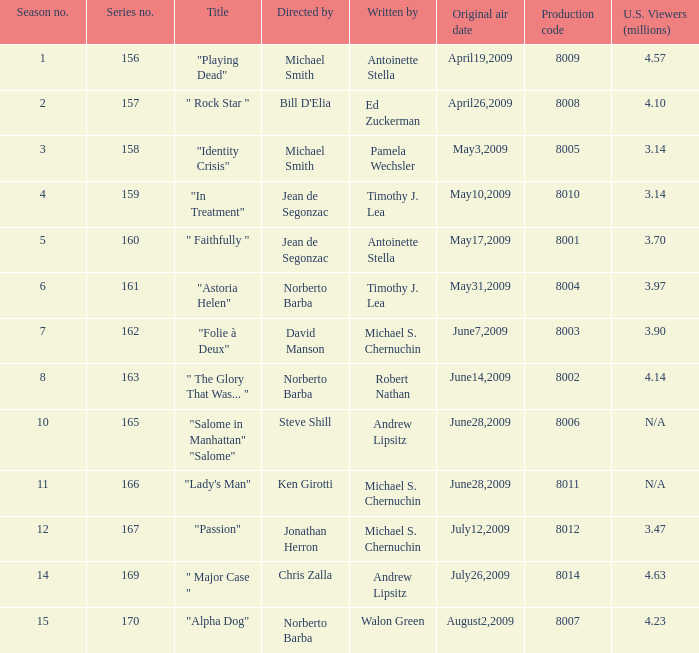Which is the biggest production code? 8014.0. 